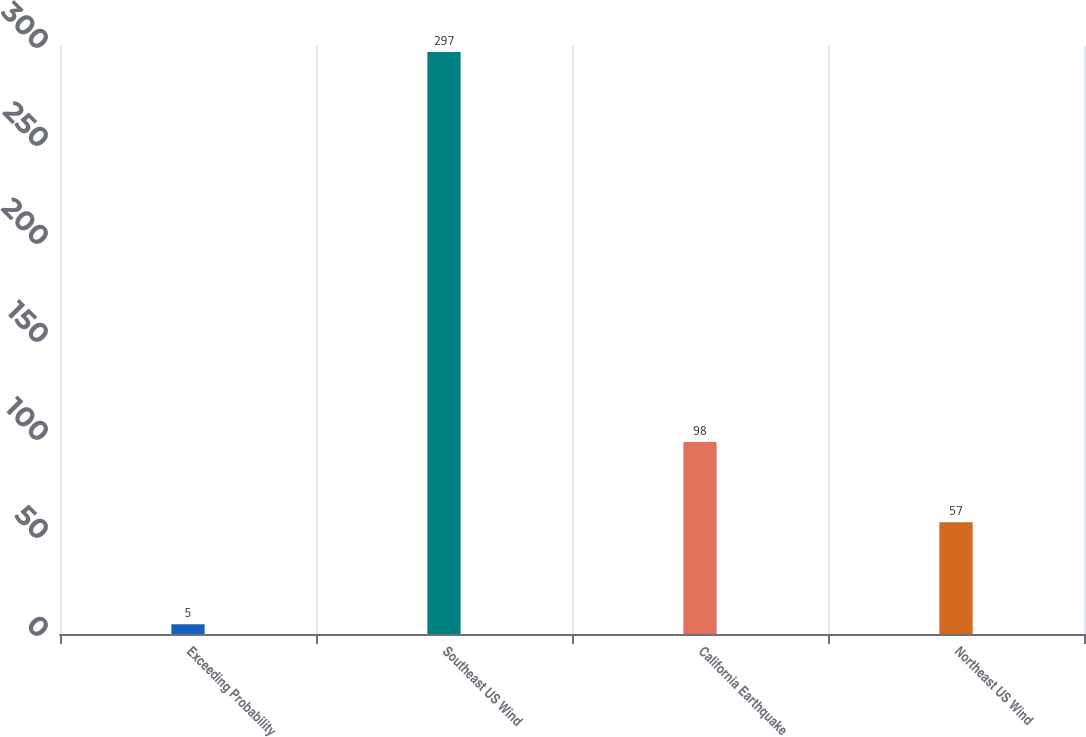Convert chart. <chart><loc_0><loc_0><loc_500><loc_500><bar_chart><fcel>Exceeding Probability<fcel>Southeast US Wind<fcel>California Earthquake<fcel>Northeast US Wind<nl><fcel>5<fcel>297<fcel>98<fcel>57<nl></chart> 